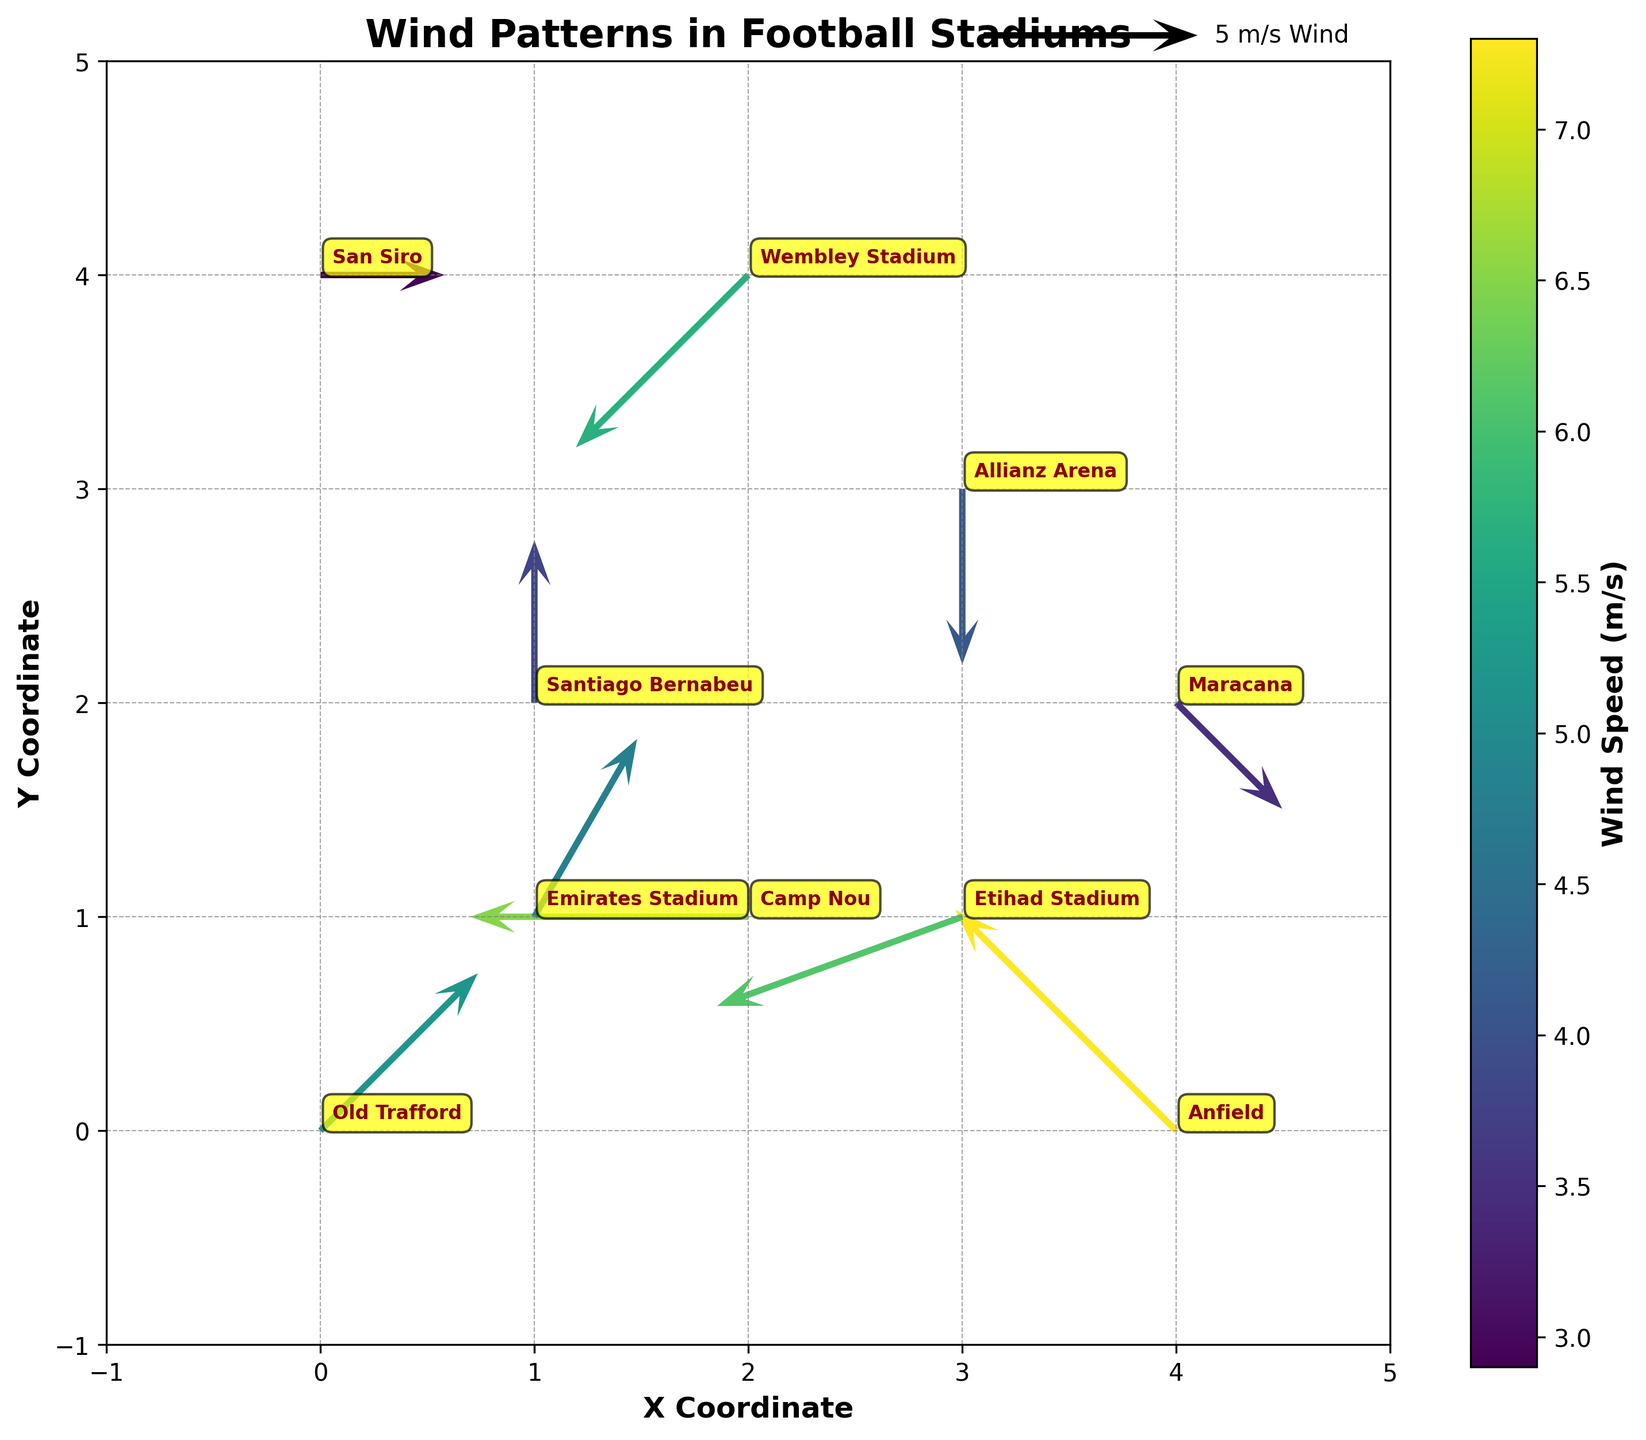What is the wind speed at Old Trafford? The quiver plot includes annotations for each stadium. By looking at Old Trafford, we see its annotation indicating the wind speed.
Answer: 5.2 m/s Which stadium has the highest wind speed? The colorbar indicates wind speeds, and the length of vectors represents their magnitude. By observing both, we find Anfield has the longest vector, indicating the highest wind speed.
Answer: Anfield What direction is the wind blowing at Camp Nou? The quiver plot vectors indicate wind direction with arrows pointing towards the direction of wind. Camp Nou's vector points downward, which corresponds to 180 degrees.
Answer: 180 degrees How does the wind speed at Santiago Bernabeu compare to that at Allianz Arena? By comparing the color of the vectors and consulting the colorbar, we determine the relative wind speed. Santiago Bernabeu has a slightly lower wind speed (3.8 m/s) than Allianz Arena (4.1 m/s).
Answer: Santiago Bernabeu has a lower wind speed than Allianz Arena Which stadium experiences wind coming from the southwest? Wind coming from the southwest would have a direction of around 225 degrees. By looking at the vectors and their directions, we see Wembley Stadium experiences wind from the southwest.
Answer: Wembley Stadium How does the wind direction at Allianz Arena differ from that at Old Trafford? Comparing the vectors, Allianz Arena's wind direction vector points left (270 degrees), while Old Trafford's vector points diagonally upward-right (45 degrees).
Answer: Allianz Arena has a wind direction of 270 degrees, Old Trafford has 45 degrees In terms of the wind's potential effect on long passes, which stadium's wind patterns would most likely disrupt accurate long passes? We look for the stadium with the highest wind speed and direction that could impact flight of the ball. Anfield, with the highest speed and a direction possibly affecting longitudinal passes, stands out.
Answer: Anfield 